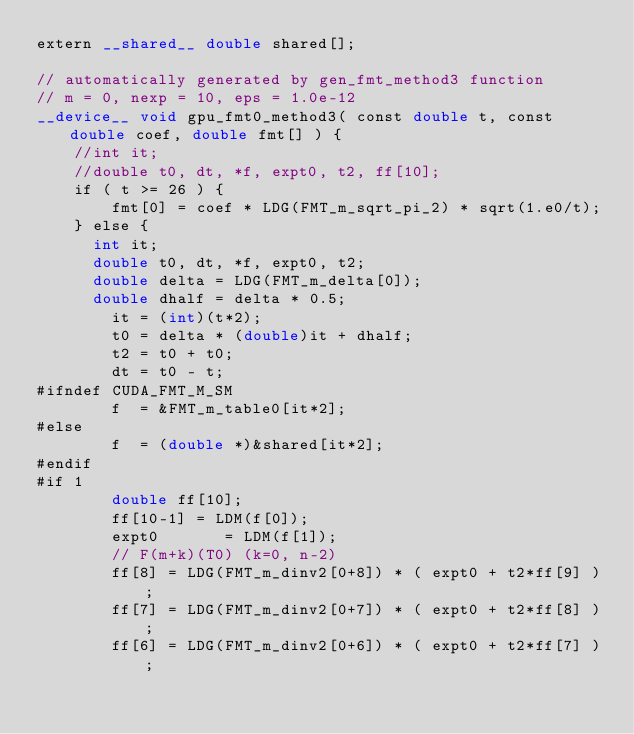Convert code to text. <code><loc_0><loc_0><loc_500><loc_500><_Cuda_>extern __shared__ double shared[];

// automatically generated by gen_fmt_method3 function
// m = 0, nexp = 10, eps = 1.0e-12
__device__ void gpu_fmt0_method3( const double t, const double coef, double fmt[] ) {
    //int it;
    //double t0, dt, *f, expt0, t2, ff[10];
    if ( t >= 26 ) {
        fmt[0] = coef * LDG(FMT_m_sqrt_pi_2) * sqrt(1.e0/t);
    } else {
      int it;
      double t0, dt, *f, expt0, t2;
      double delta = LDG(FMT_m_delta[0]);
      double dhalf = delta * 0.5;
        it = (int)(t*2);
        t0 = delta * (double)it + dhalf;
        t2 = t0 + t0;
        dt = t0 - t;
#ifndef CUDA_FMT_M_SM
        f  = &FMT_m_table0[it*2];
#else
        f  = (double *)&shared[it*2];
#endif
#if 1
        double ff[10];
        ff[10-1] = LDM(f[0]);
        expt0       = LDM(f[1]);
        // F(m+k)(T0) (k=0, n-2)
        ff[8] = LDG(FMT_m_dinv2[0+8]) * ( expt0 + t2*ff[9] );
        ff[7] = LDG(FMT_m_dinv2[0+7]) * ( expt0 + t2*ff[8] );
        ff[6] = LDG(FMT_m_dinv2[0+6]) * ( expt0 + t2*ff[7] );</code> 